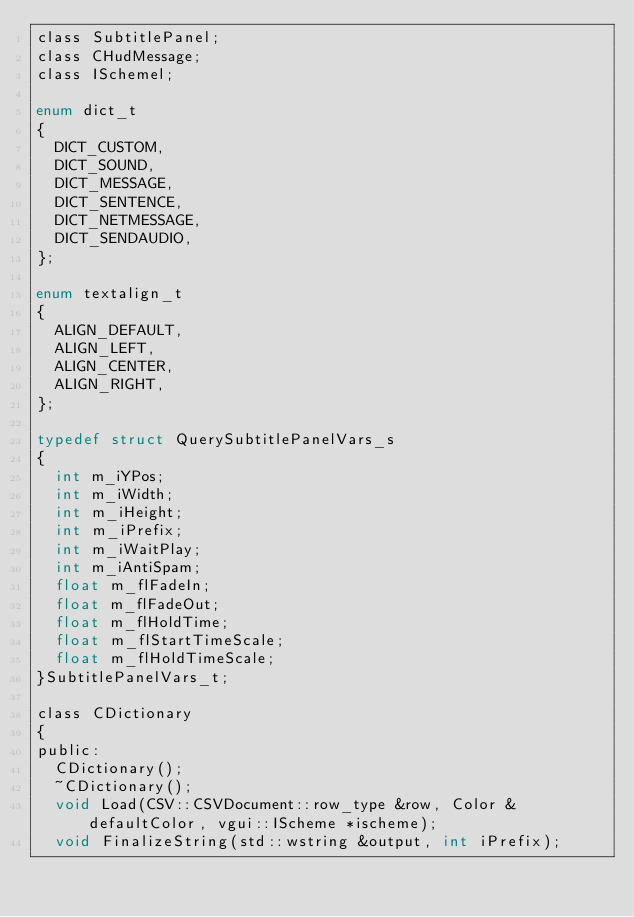<code> <loc_0><loc_0><loc_500><loc_500><_C_>class SubtitlePanel;
class CHudMessage;
class ISchemel;

enum dict_t
{
	DICT_CUSTOM,
	DICT_SOUND,
	DICT_MESSAGE,
	DICT_SENTENCE,
	DICT_NETMESSAGE,
	DICT_SENDAUDIO,
};

enum textalign_t
{
	ALIGN_DEFAULT,
	ALIGN_LEFT,
	ALIGN_CENTER,
	ALIGN_RIGHT,
};

typedef struct QuerySubtitlePanelVars_s
{
	int m_iYPos;
	int m_iWidth;
	int m_iHeight;
	int m_iPrefix;
	int m_iWaitPlay;
	int m_iAntiSpam;
	float m_flFadeIn;
	float m_flFadeOut;
	float m_flHoldTime;
	float m_flStartTimeScale;
	float m_flHoldTimeScale;
}SubtitlePanelVars_t;

class CDictionary
{
public:
	CDictionary();
	~CDictionary();
	void Load(CSV::CSVDocument::row_type &row, Color &defaultColor, vgui::IScheme *ischeme);
	void FinalizeString(std::wstring &output, int iPrefix);
</code> 